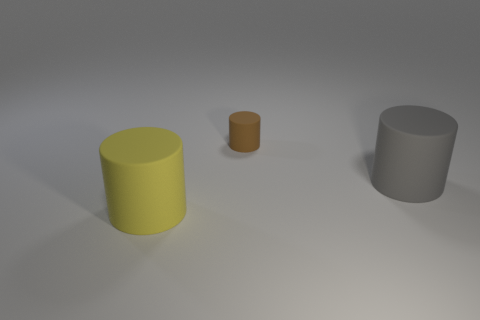Subtract all tiny brown cylinders. How many cylinders are left? 2 Add 3 rubber cylinders. How many objects exist? 6 Subtract all yellow cylinders. How many cylinders are left? 2 Subtract 0 purple spheres. How many objects are left? 3 Subtract 1 cylinders. How many cylinders are left? 2 Subtract all cyan cylinders. Subtract all blue balls. How many cylinders are left? 3 Subtract all blue spheres. How many blue cylinders are left? 0 Subtract all tiny red cubes. Subtract all big rubber cylinders. How many objects are left? 1 Add 1 big yellow things. How many big yellow things are left? 2 Add 2 tiny yellow things. How many tiny yellow things exist? 2 